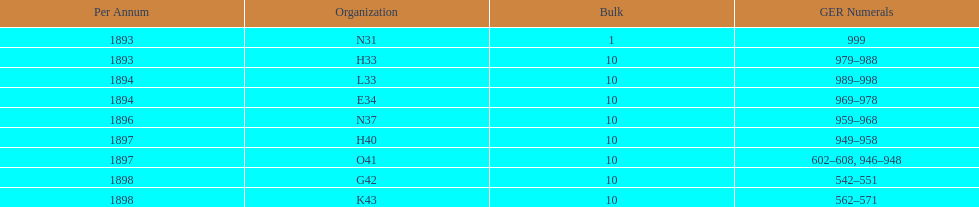How many years are listed? 5. 